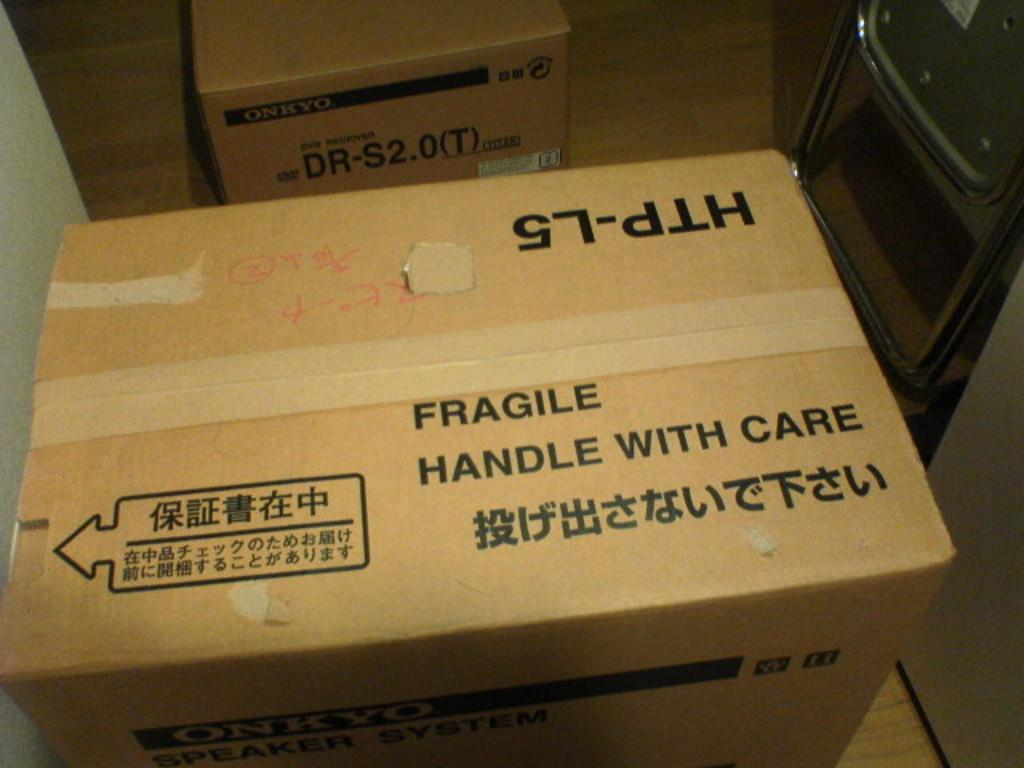<image>
Create a compact narrative representing the image presented. a box with Japanese letter reads Fragile Handle with Care 